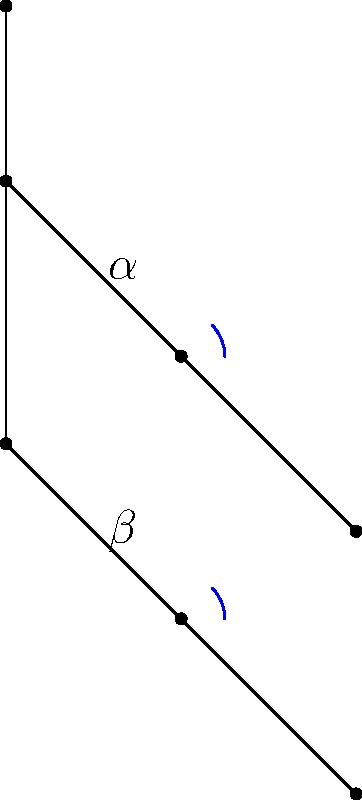In this body pose estimation diagram for a squat exercise, which angle should be approximately 90 degrees for proper form, and how does this relate to the effectiveness of the exercise? To answer this question, let's analyze the diagram step-by-step:

1. The diagram shows a simplified stick figure representation of a person performing a squat exercise.

2. There are two main angles highlighted in the diagram:
   - $\alpha$: the angle at the elbow joint
   - $\beta$: the angle at the knee joint

3. For proper squat form, the focus is on the lower body, particularly the knee angle ($\beta$).

4. In a proper squat:
   - The knee angle ($\beta$) should be approximately 90 degrees at the bottom of the movement.
   - This 90-degree angle ensures that the thighs are parallel to the ground.

5. The importance of the 90-degree knee angle:
   - It maximizes muscle engagement in the quadriceps, hamstrings, and glutes.
   - It helps maintain proper balance and prevents excessive forward lean.
   - It reduces stress on the knee joint by distributing the load evenly.

6. The elbow angle ($\alpha$) is less critical for the squat exercise but may be relevant for upper body positioning or if holding weights.

7. Maintaining proper form with the 90-degree knee angle:
   - Increases exercise effectiveness by targeting the intended muscle groups.
   - Reduces the risk of injury by maintaining proper alignment of joints.
   - Allows for a full range of motion, promoting flexibility and strength gains.

Therefore, the knee angle ($\beta$) should be approximately 90 degrees for proper squat form, which is crucial for maximizing the effectiveness of the exercise and minimizing the risk of injury.
Answer: Knee angle ($\beta$); maximizes muscle engagement and reduces injury risk 